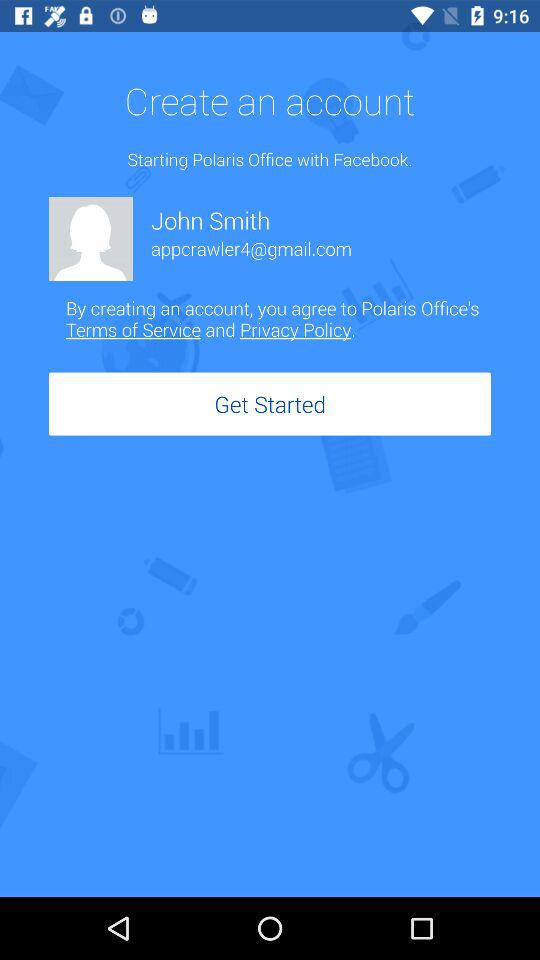What is the name of the user? The name of the user is John Smith. 